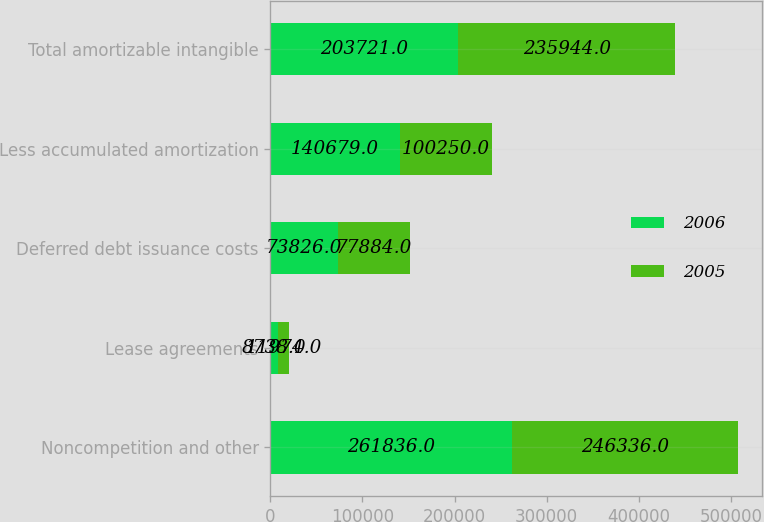<chart> <loc_0><loc_0><loc_500><loc_500><stacked_bar_chart><ecel><fcel>Noncompetition and other<fcel>Lease agreements<fcel>Deferred debt issuance costs<fcel>Less accumulated amortization<fcel>Total amortizable intangible<nl><fcel>2006<fcel>261836<fcel>8738<fcel>73826<fcel>140679<fcel>203721<nl><fcel>2005<fcel>246336<fcel>11974<fcel>77884<fcel>100250<fcel>235944<nl></chart> 